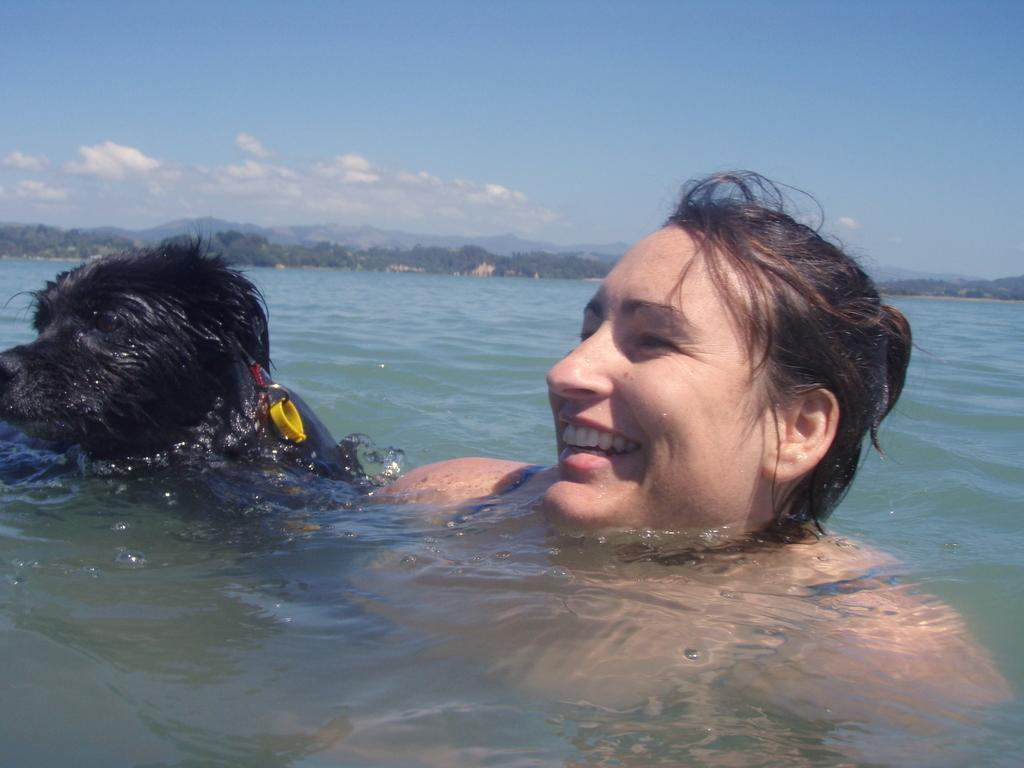What are the people in the image doing? The people in the image are in the water. What can be seen in the background of the image? There are trees and mountains visible in the background of the image. How would you describe the sky in the image? The sky is blue and cloudy in the image. What degree of difficulty is the person performing in the water? There is no indication of any performance or difficulty level in the image; it simply shows people in the water. 